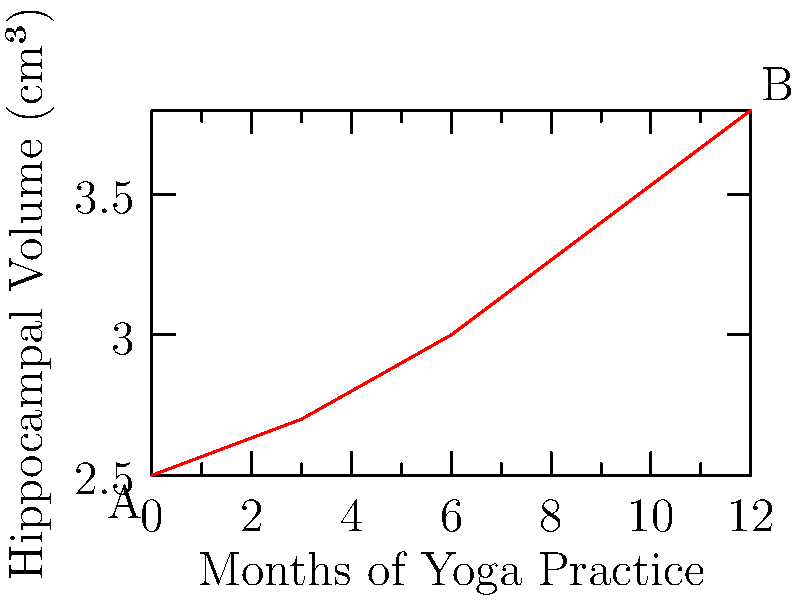Based on the graph showing the relationship between months of yoga practice and hippocampal volume, calculate the average rate of change in hippocampal volume (in cm³ per month) over the 12-month period. What does this suggest about the potential effects of long-term yoga practice on brain structure? To solve this problem, we'll follow these steps:

1. Identify the initial and final points:
   Point A (0 months, 2.5 cm³)
   Point B (12 months, 3.8 cm³)

2. Calculate the total change in hippocampal volume:
   $\Delta y = 3.8 \text{ cm³} - 2.5 \text{ cm³} = 1.3 \text{ cm³}$

3. Calculate the total time period:
   $\Delta x = 12 \text{ months} - 0 \text{ months} = 12 \text{ months}$

4. Calculate the average rate of change:
   $\text{Rate of change} = \frac{\Delta y}{\Delta x} = \frac{1.3 \text{ cm³}}{12 \text{ months}} = 0.108333... \text{ cm³/month}$

5. Round to a reasonable number of decimal places:
   $0.108333... \approx 0.11 \text{ cm³/month}$

This result suggests that, on average, the hippocampal volume increased by approximately 0.11 cm³ per month over the 12-month period of yoga practice.

Interpretation:
The positive rate of change indicates a consistent increase in hippocampal volume over time with continued yoga practice. This suggests that long-term yoga practice may have a beneficial effect on brain structure, particularly in the hippocampus, which is associated with memory and learning. The steady upward trend implies that the effects of yoga on brain structure may be cumulative and sustained over time.

For a neurologist exploring the connection between yoga and the brain, this data provides evidence supporting the potential of yoga as a non-invasive intervention for maintaining or improving brain health. It also suggests that the duration of yoga practice may be an important factor in realizing these benefits, which could inform the development of yoga-based treatment approaches for neurological conditions affecting hippocampal function.
Answer: 0.11 cm³/month; suggests potential cumulative, positive effects of long-term yoga practice on hippocampal volume. 